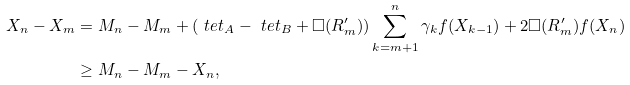<formula> <loc_0><loc_0><loc_500><loc_500>X _ { n } - X _ { m } & = M _ { n } - M _ { m } + ( \ t e t _ { A } - \ t e t _ { B } + \Box ( R ^ { \prime } _ { m } ) ) \sum _ { k = m + 1 } ^ { n } \gamma _ { k } f ( X _ { k - 1 } ) + 2 \Box ( R ^ { \prime } _ { m } ) f ( X _ { n } ) \\ & \geq M _ { n } - M _ { m } - X _ { n } ,</formula> 